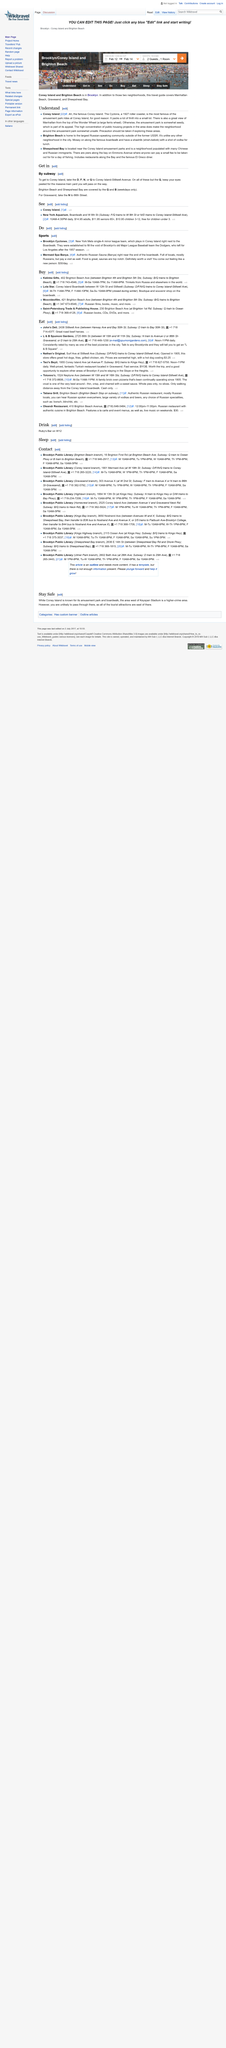Point out several critical features in this image. The Brooklyn Cyclones are a single-A minor league baseball team that competes in the New York-Penn League, representing the borough of Brooklyn in New York City. Once a user clicks the "add listing" button, they will be able to add a new listing to the list. The cost of The Mermaid Spa Banya is $30 per day. 